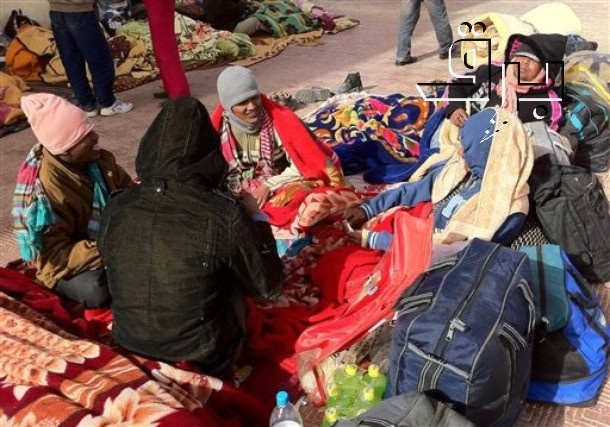Describe the objects in this image and their specific colors. I can see people in tan, black, and gray tones, backpack in tan, gray, black, and darkblue tones, suitcase in tan, gray, black, and darkblue tones, people in tan, beige, gray, and salmon tones, and people in tan, black, lightpink, gray, and maroon tones in this image. 